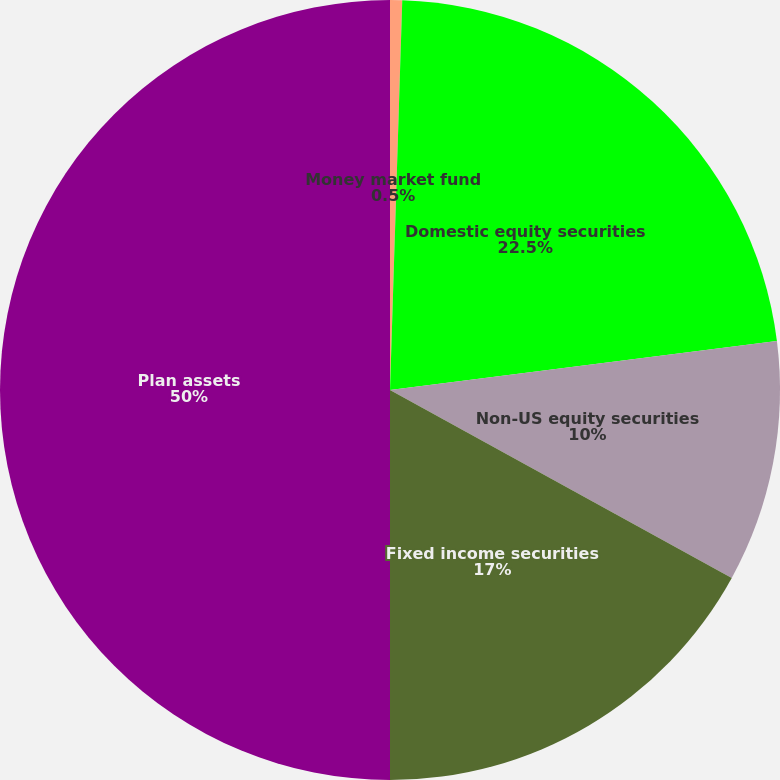Convert chart to OTSL. <chart><loc_0><loc_0><loc_500><loc_500><pie_chart><fcel>Money market fund<fcel>Domestic equity securities<fcel>Non-US equity securities<fcel>Fixed income securities<fcel>Plan assets<nl><fcel>0.5%<fcel>22.5%<fcel>10.0%<fcel>17.0%<fcel>50.0%<nl></chart> 